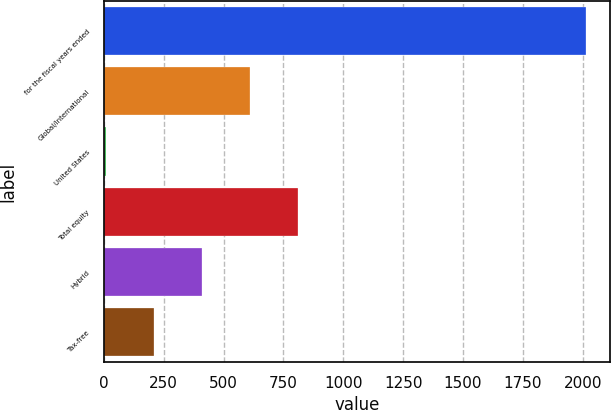Convert chart. <chart><loc_0><loc_0><loc_500><loc_500><bar_chart><fcel>for the fiscal years ended<fcel>Global/international<fcel>United States<fcel>Total equity<fcel>Hybrid<fcel>Tax-free<nl><fcel>2012<fcel>611.3<fcel>11<fcel>811.4<fcel>411.2<fcel>211.1<nl></chart> 